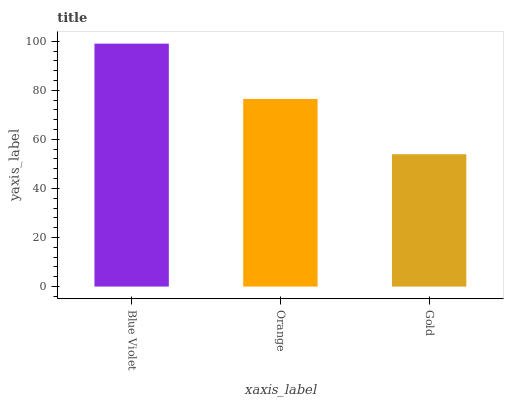Is Gold the minimum?
Answer yes or no. Yes. Is Blue Violet the maximum?
Answer yes or no. Yes. Is Orange the minimum?
Answer yes or no. No. Is Orange the maximum?
Answer yes or no. No. Is Blue Violet greater than Orange?
Answer yes or no. Yes. Is Orange less than Blue Violet?
Answer yes or no. Yes. Is Orange greater than Blue Violet?
Answer yes or no. No. Is Blue Violet less than Orange?
Answer yes or no. No. Is Orange the high median?
Answer yes or no. Yes. Is Orange the low median?
Answer yes or no. Yes. Is Blue Violet the high median?
Answer yes or no. No. Is Gold the low median?
Answer yes or no. No. 